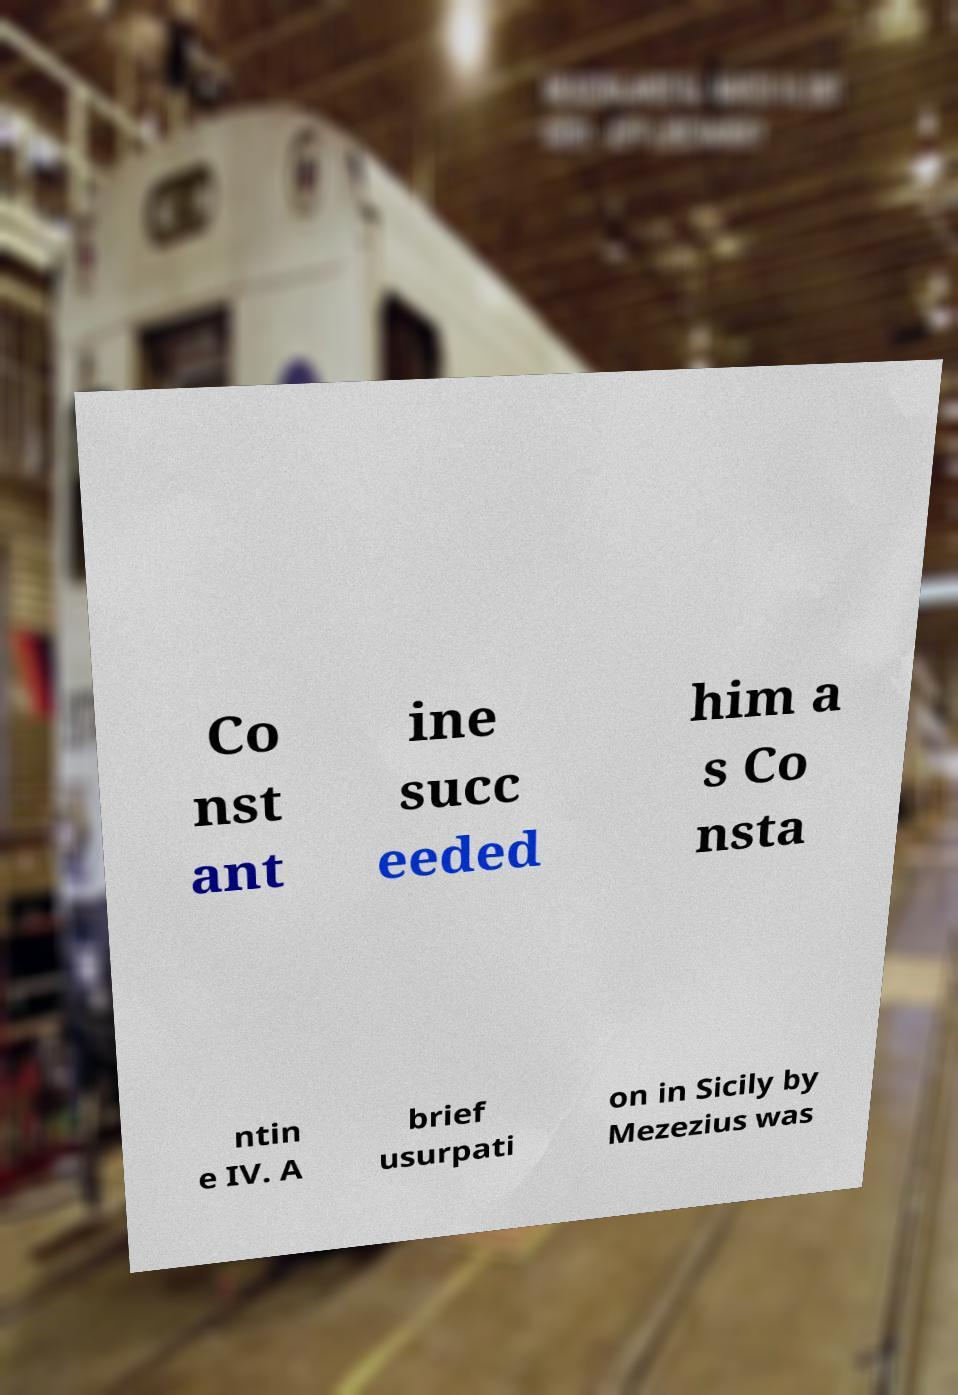Can you read and provide the text displayed in the image?This photo seems to have some interesting text. Can you extract and type it out for me? Co nst ant ine succ eeded him a s Co nsta ntin e IV. A brief usurpati on in Sicily by Mezezius was 